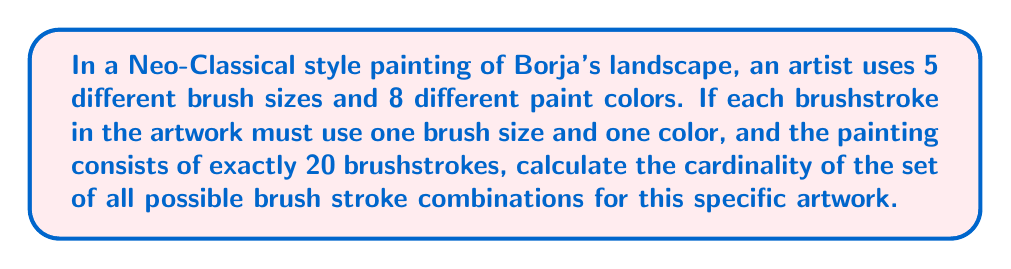Can you solve this math problem? Let's approach this step-by-step:

1) First, we need to understand what each brushstroke represents in terms of choices:
   - Each brushstroke uses one of 5 brush sizes
   - Each brushstroke uses one of 8 paint colors

2) This means that for each individual brushstroke, we have $5 \times 8 = 40$ possible combinations.

3) Now, we need to consider that the artwork consists of exactly 20 brushstrokes. For each of these 20 positions, we have 40 choices.

4) This scenario represents a case of choosing with replacement (as we can use the same brush size and color multiple times) and where the order matters (as changing the order of brushstrokes would create a different artwork).

5) In such cases, we use the multiplication principle. The total number of possible combinations is:

   $$ 40^{20} $$

6) This is because for each of the 20 positions, we have 40 choices, and we multiply these together.

7) To calculate the cardinality, we just need to evaluate this expression:

   $$ 40^{20} = 1.0995116 \times 10^{32} $$

This extremely large number represents the cardinality of the set of all possible brush stroke combinations for this specific artwork.
Answer: The cardinality of the set of all possible brush stroke combinations is $40^{20} \approx 1.0995116 \times 10^{32}$. 